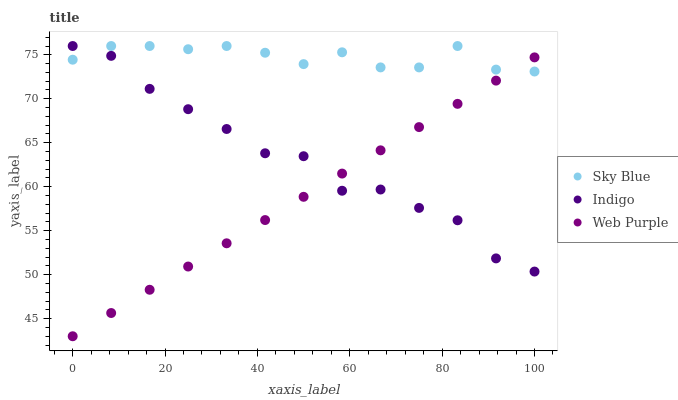Does Web Purple have the minimum area under the curve?
Answer yes or no. Yes. Does Sky Blue have the maximum area under the curve?
Answer yes or no. Yes. Does Indigo have the minimum area under the curve?
Answer yes or no. No. Does Indigo have the maximum area under the curve?
Answer yes or no. No. Is Web Purple the smoothest?
Answer yes or no. Yes. Is Indigo the roughest?
Answer yes or no. Yes. Is Indigo the smoothest?
Answer yes or no. No. Is Web Purple the roughest?
Answer yes or no. No. Does Web Purple have the lowest value?
Answer yes or no. Yes. Does Indigo have the lowest value?
Answer yes or no. No. Does Indigo have the highest value?
Answer yes or no. Yes. Does Web Purple have the highest value?
Answer yes or no. No. Does Sky Blue intersect Indigo?
Answer yes or no. Yes. Is Sky Blue less than Indigo?
Answer yes or no. No. Is Sky Blue greater than Indigo?
Answer yes or no. No. 